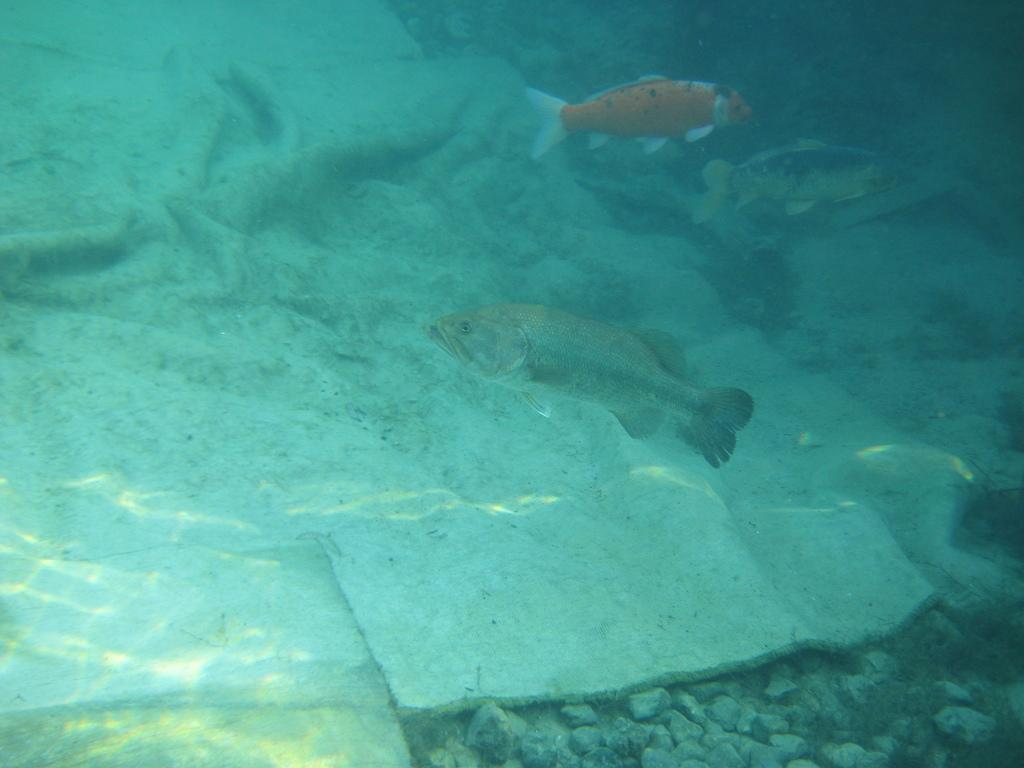What is the main subject in the foreground of the image? There is a water body in the foreground of the image. What can be seen inside the water body? There are three fishes in the water body. What type of skirt is the fish wearing in the image? There are no fish wearing skirts in the image, as fish do not wear clothing. 